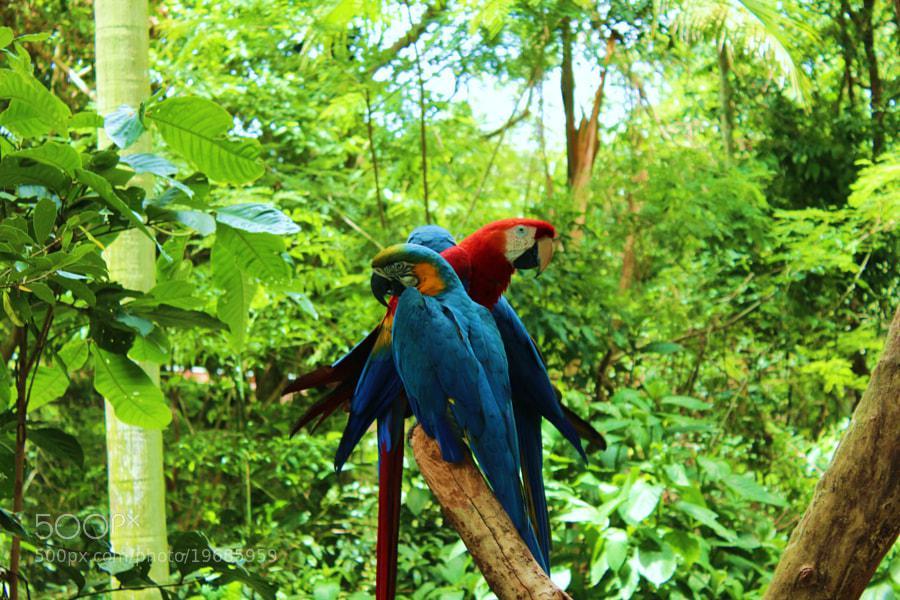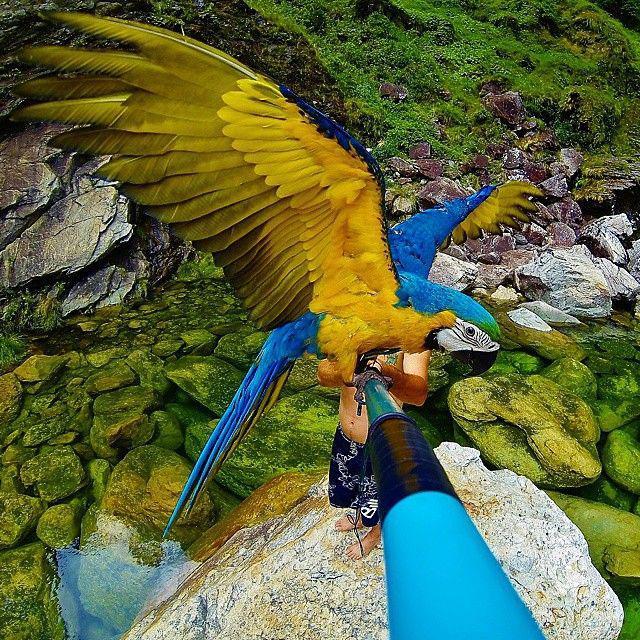The first image is the image on the left, the second image is the image on the right. Analyze the images presented: Is the assertion "In one image there are four blue birds perched on a branch." valid? Answer yes or no. No. The first image is the image on the left, the second image is the image on the right. Given the left and right images, does the statement "The right image features a blue-and-yellow parrot only, and the left image includes at least one red-headed parrot." hold true? Answer yes or no. Yes. 